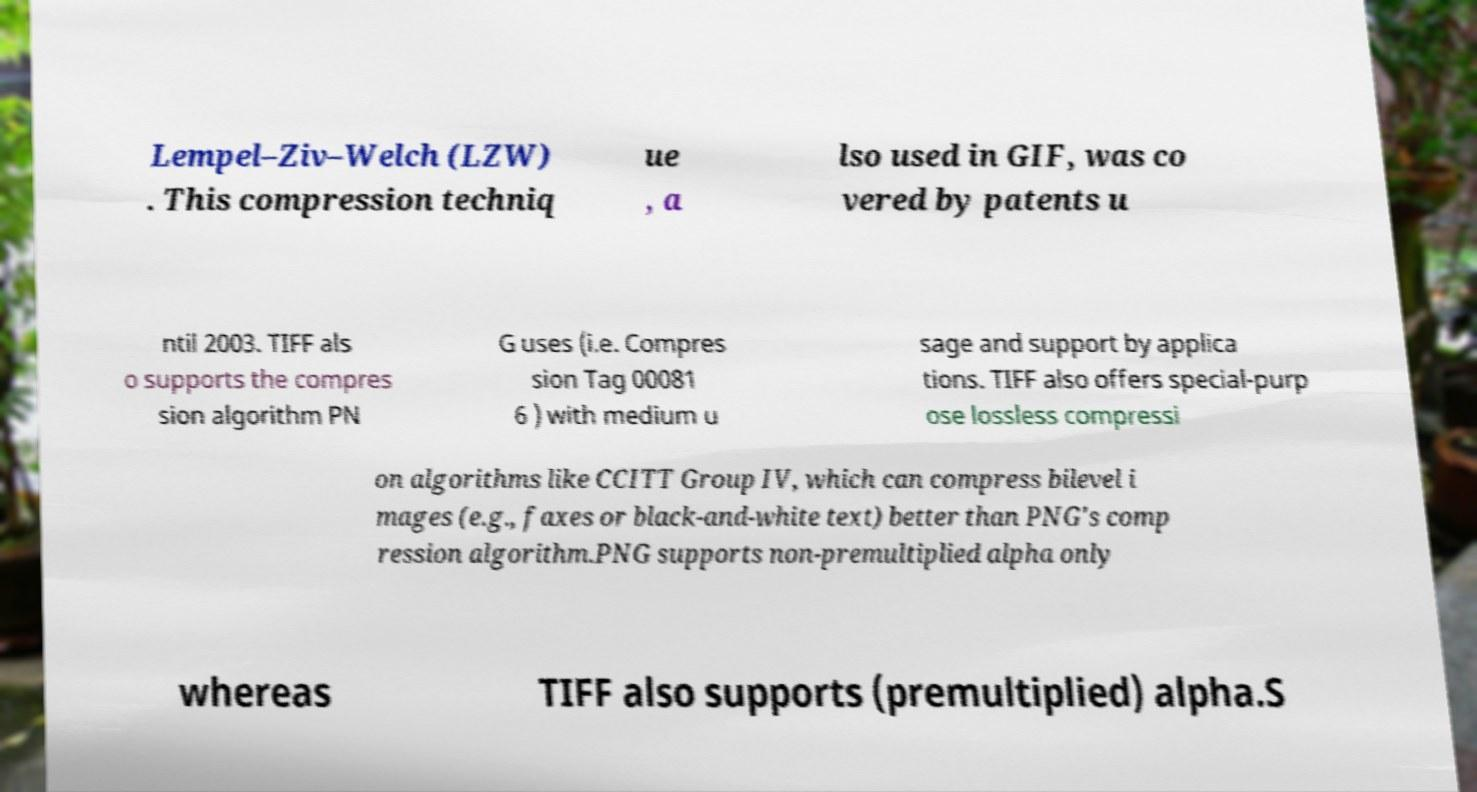Please identify and transcribe the text found in this image. Lempel–Ziv–Welch (LZW) . This compression techniq ue , a lso used in GIF, was co vered by patents u ntil 2003. TIFF als o supports the compres sion algorithm PN G uses (i.e. Compres sion Tag 00081 6 ) with medium u sage and support by applica tions. TIFF also offers special-purp ose lossless compressi on algorithms like CCITT Group IV, which can compress bilevel i mages (e.g., faxes or black-and-white text) better than PNG's comp ression algorithm.PNG supports non-premultiplied alpha only whereas TIFF also supports (premultiplied) alpha.S 